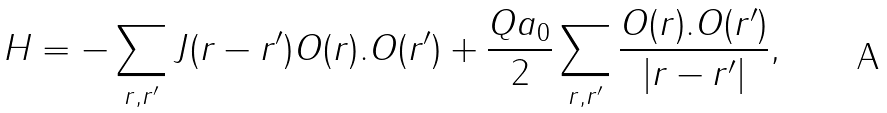Convert formula to latex. <formula><loc_0><loc_0><loc_500><loc_500>H = - \sum _ { { r } , { r ^ { \prime } } } J ( { r } - { r ^ { \prime } } ) { O ( r ) } { . } { O ( r ^ { \prime } ) } + \frac { Q a _ { 0 } } { 2 } \sum _ { { r } , { r ^ { \prime } } } \frac { { O ( r ) } { . } { O ( r ^ { \prime } ) } } { | { r } - { r ^ { \prime } } | } ,</formula> 